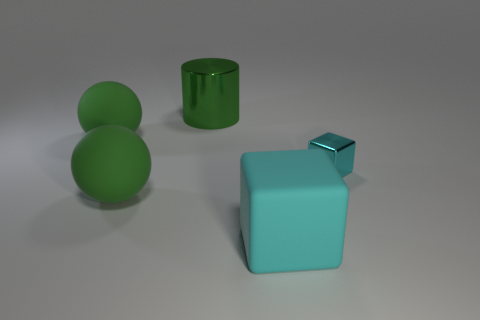Add 2 cyan shiny blocks. How many objects exist? 7 Subtract all cylinders. How many objects are left? 4 Add 3 large green rubber balls. How many large green rubber balls exist? 5 Subtract 0 yellow cylinders. How many objects are left? 5 Subtract all cyan rubber cubes. Subtract all balls. How many objects are left? 2 Add 3 shiny cylinders. How many shiny cylinders are left? 4 